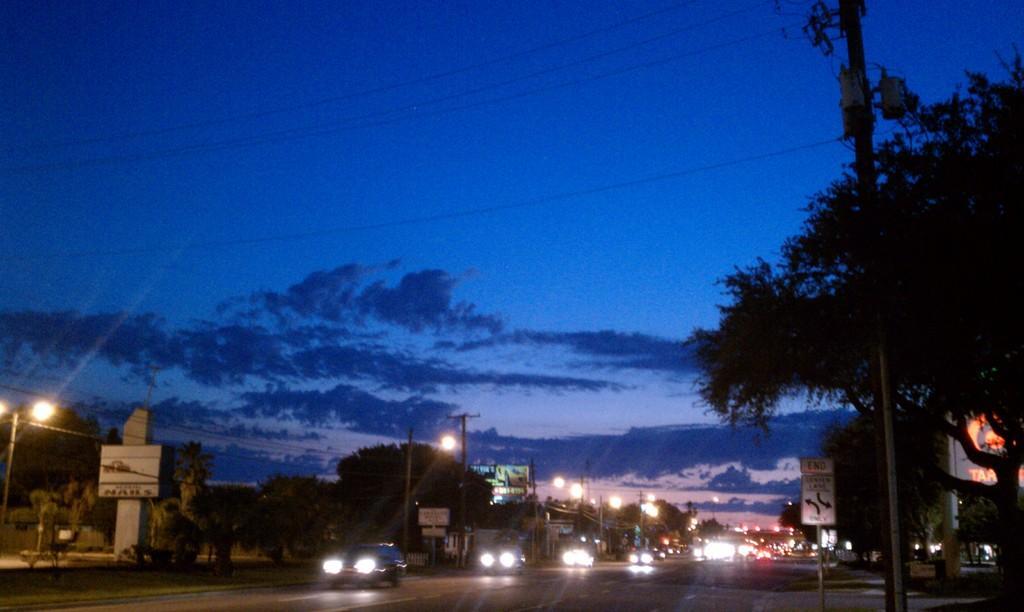Could you give a brief overview of what you see in this image? In the foreground of the image we can see a road, cars, street lights and trees. In the middle of the image we can see the sky and a tree. On the top of the image we can see the sky and current wires. 